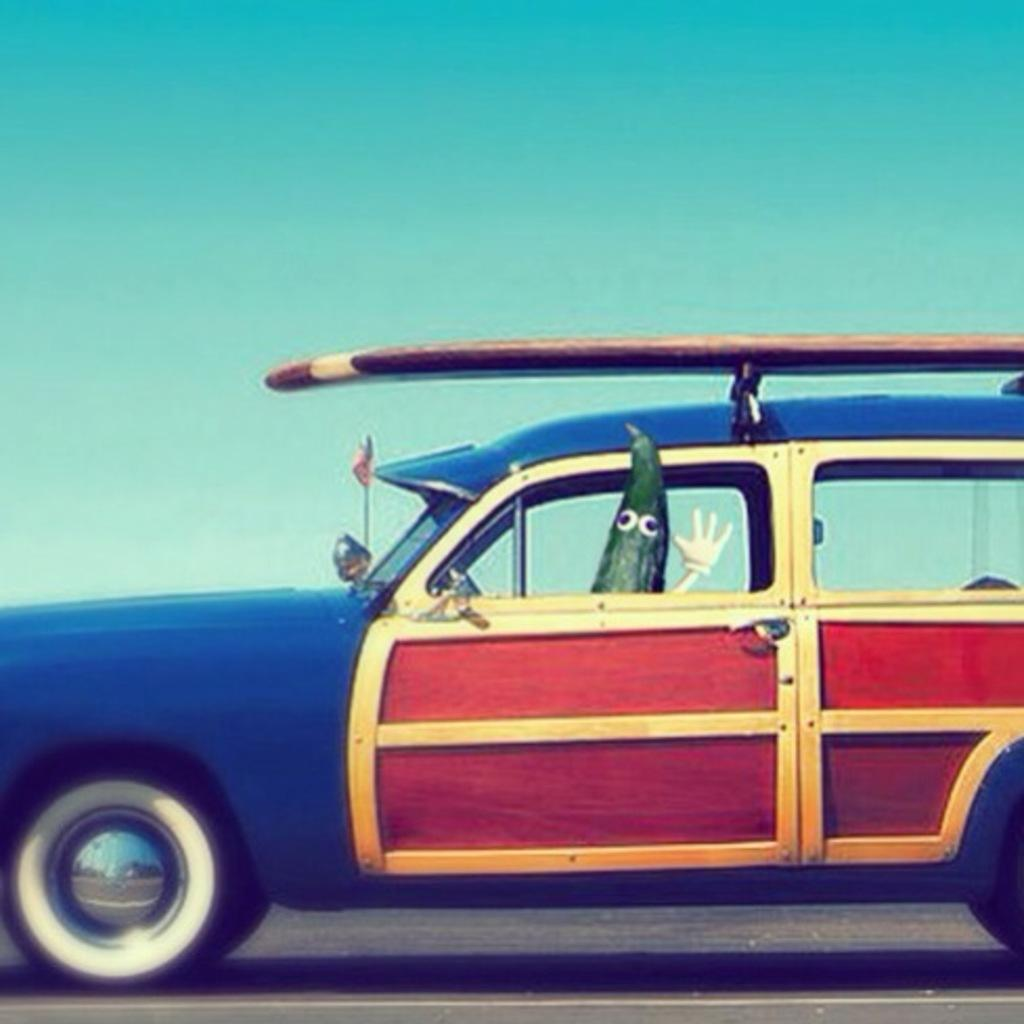What type of image is this? The image is animated. What is the main subject in the center of the image? There is a car in the center of the image. What is inside the car? There is a toy in the car. What can be seen in the background of the image? The sky is visible in the background of the image. What type of hook is hanging from the toy in the car? There is no hook present in the image, as the toy inside the car does not have any visible hooks. 